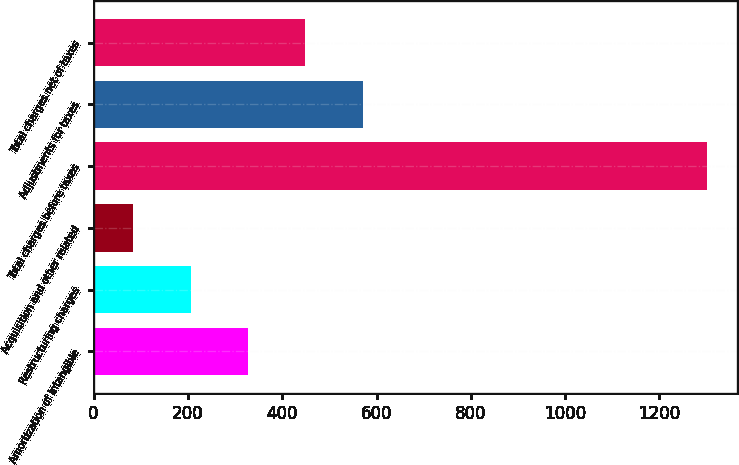Convert chart to OTSL. <chart><loc_0><loc_0><loc_500><loc_500><bar_chart><fcel>Amortization of intangible<fcel>Restructuring charges<fcel>Acquisition and other related<fcel>Total charges before taxes<fcel>Adjustments for taxes<fcel>Total charges net of taxes<nl><fcel>327.2<fcel>205.6<fcel>84<fcel>1300<fcel>570.4<fcel>448.8<nl></chart> 